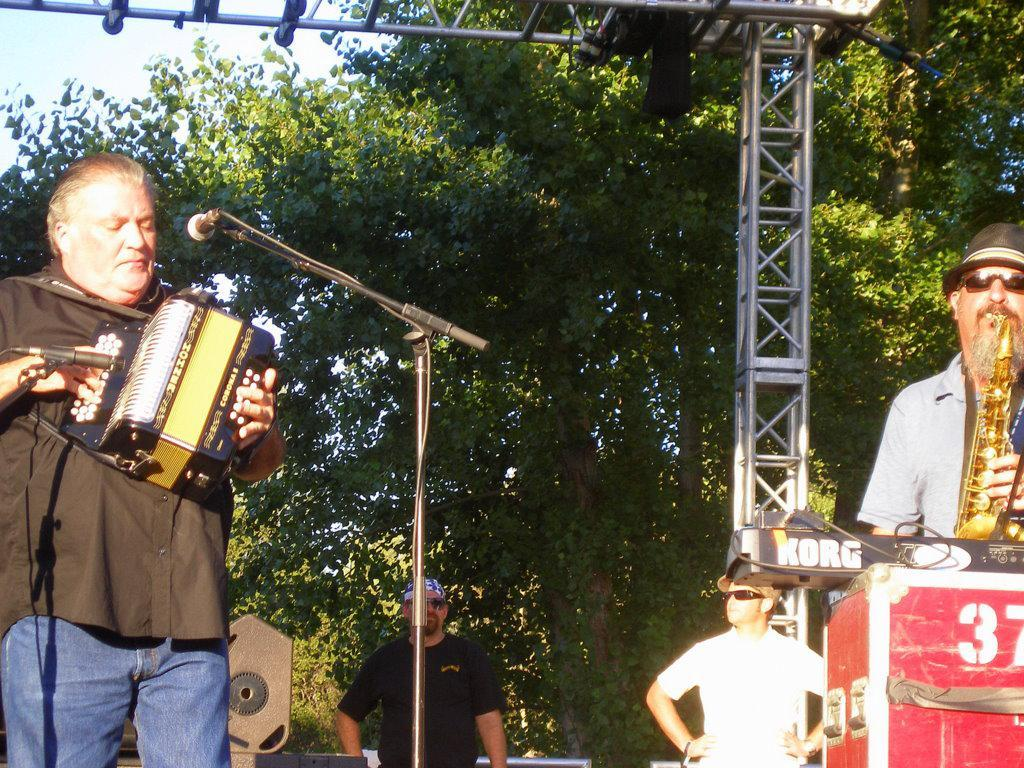How many people are in the image? There are two people in the image. What are the people doing in the image? The people are playing musical instruments. What object is present for amplifying sound in the image? There is a microphone (mic) in the image. What type of objects can be seen that are used for playing the instruments? There are rods in the image, which might be used for playing the instruments. What natural element is visible in the image? There is a tree in the image. What type of history lesson is being taught by the people in the image? There is no indication of a history lesson in the image; the people are playing musical instruments. Can you see any sacks or shoes in the image? No, there are no sacks or shoes visible in the image. 